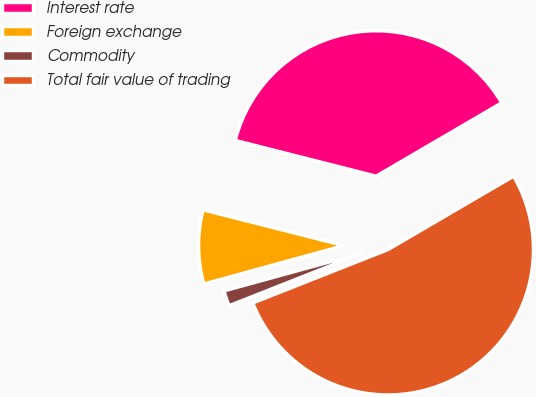<chart> <loc_0><loc_0><loc_500><loc_500><pie_chart><fcel>Interest rate<fcel>Foreign exchange<fcel>Commodity<fcel>Total fair value of trading<nl><fcel>37.63%<fcel>8.22%<fcel>1.72%<fcel>52.43%<nl></chart> 